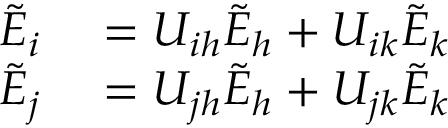<formula> <loc_0><loc_0><loc_500><loc_500>\begin{array} { r l } { \tilde { E } _ { i } } & = U _ { i h } \tilde { E } _ { h } + U _ { i k } \tilde { E } _ { k } } \\ { \tilde { E } _ { j } } & = U _ { j h } \tilde { E } _ { h } + U _ { j k } \tilde { E } _ { k } } \end{array}</formula> 